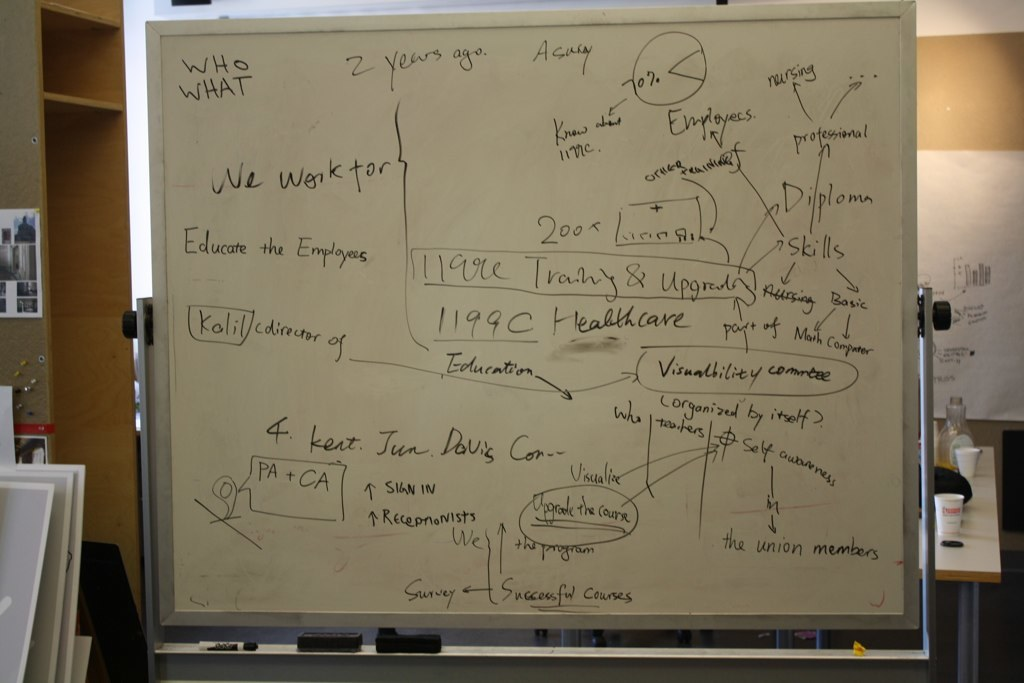Describe the main themes depicted on the whiteboard. The whiteboard captures themes related to employee education and healthcare sector improvements, including training programs, staff development, and organizational details for educating healthcare workers. 